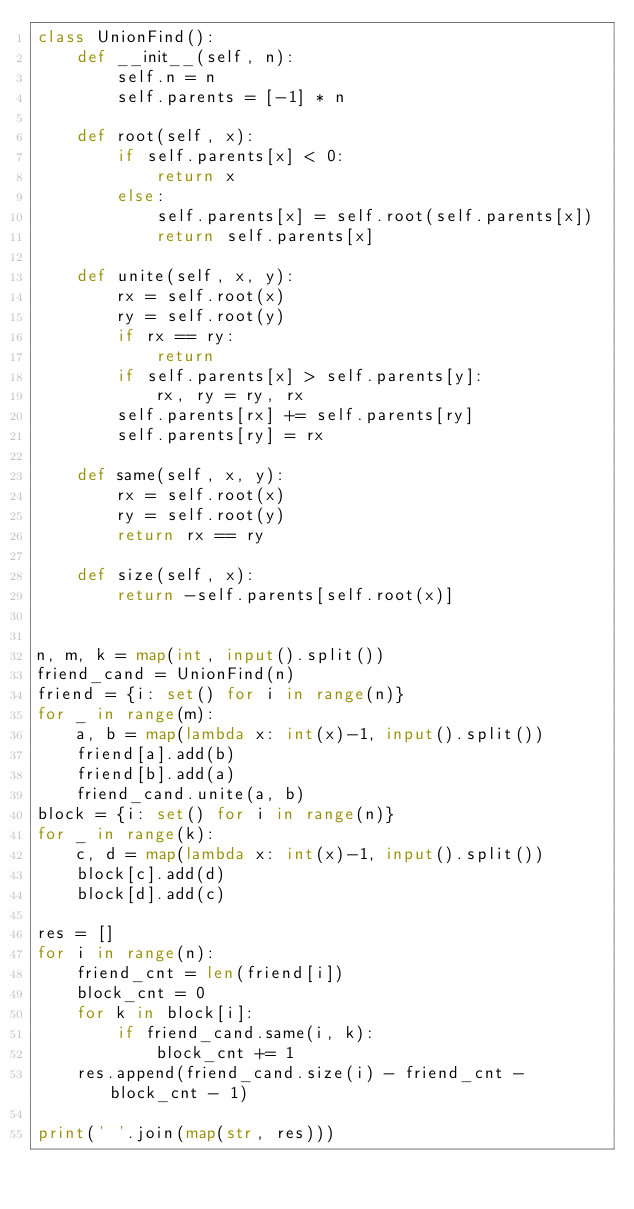Convert code to text. <code><loc_0><loc_0><loc_500><loc_500><_Python_>class UnionFind():
    def __init__(self, n):
        self.n = n
        self.parents = [-1] * n

    def root(self, x):
        if self.parents[x] < 0:
            return x
        else:
            self.parents[x] = self.root(self.parents[x])
            return self.parents[x]

    def unite(self, x, y):
        rx = self.root(x)
        ry = self.root(y)
        if rx == ry:
            return
        if self.parents[x] > self.parents[y]:
            rx, ry = ry, rx
        self.parents[rx] += self.parents[ry]
        self.parents[ry] = rx

    def same(self, x, y):
        rx = self.root(x)
        ry = self.root(y)
        return rx == ry

    def size(self, x):
        return -self.parents[self.root(x)]


n, m, k = map(int, input().split())
friend_cand = UnionFind(n)
friend = {i: set() for i in range(n)}
for _ in range(m):
    a, b = map(lambda x: int(x)-1, input().split())
    friend[a].add(b)
    friend[b].add(a)
    friend_cand.unite(a, b)
block = {i: set() for i in range(n)}
for _ in range(k):
    c, d = map(lambda x: int(x)-1, input().split())
    block[c].add(d)
    block[d].add(c)

res = []
for i in range(n):
    friend_cnt = len(friend[i])
    block_cnt = 0
    for k in block[i]:
        if friend_cand.same(i, k):
            block_cnt += 1
    res.append(friend_cand.size(i) - friend_cnt - block_cnt - 1)

print(' '.join(map(str, res)))
</code> 